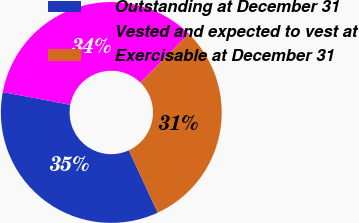Convert chart. <chart><loc_0><loc_0><loc_500><loc_500><pie_chart><fcel>Outstanding at December 31<fcel>Vested and expected to vest at<fcel>Exercisable at December 31<nl><fcel>34.86%<fcel>34.41%<fcel>30.72%<nl></chart> 